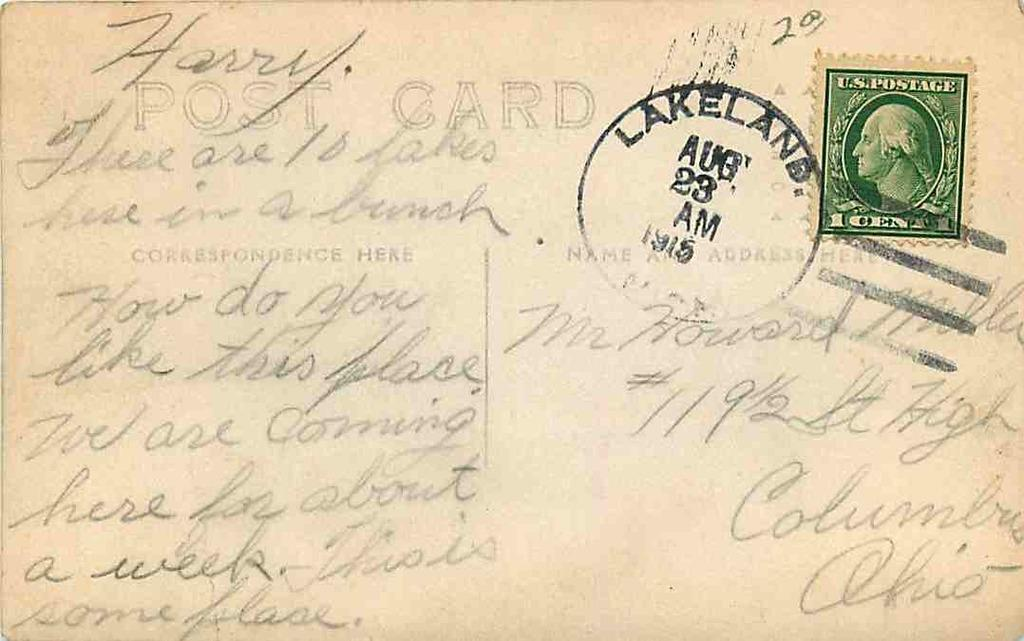<image>
Write a terse but informative summary of the picture. the word card is on the tan letter 